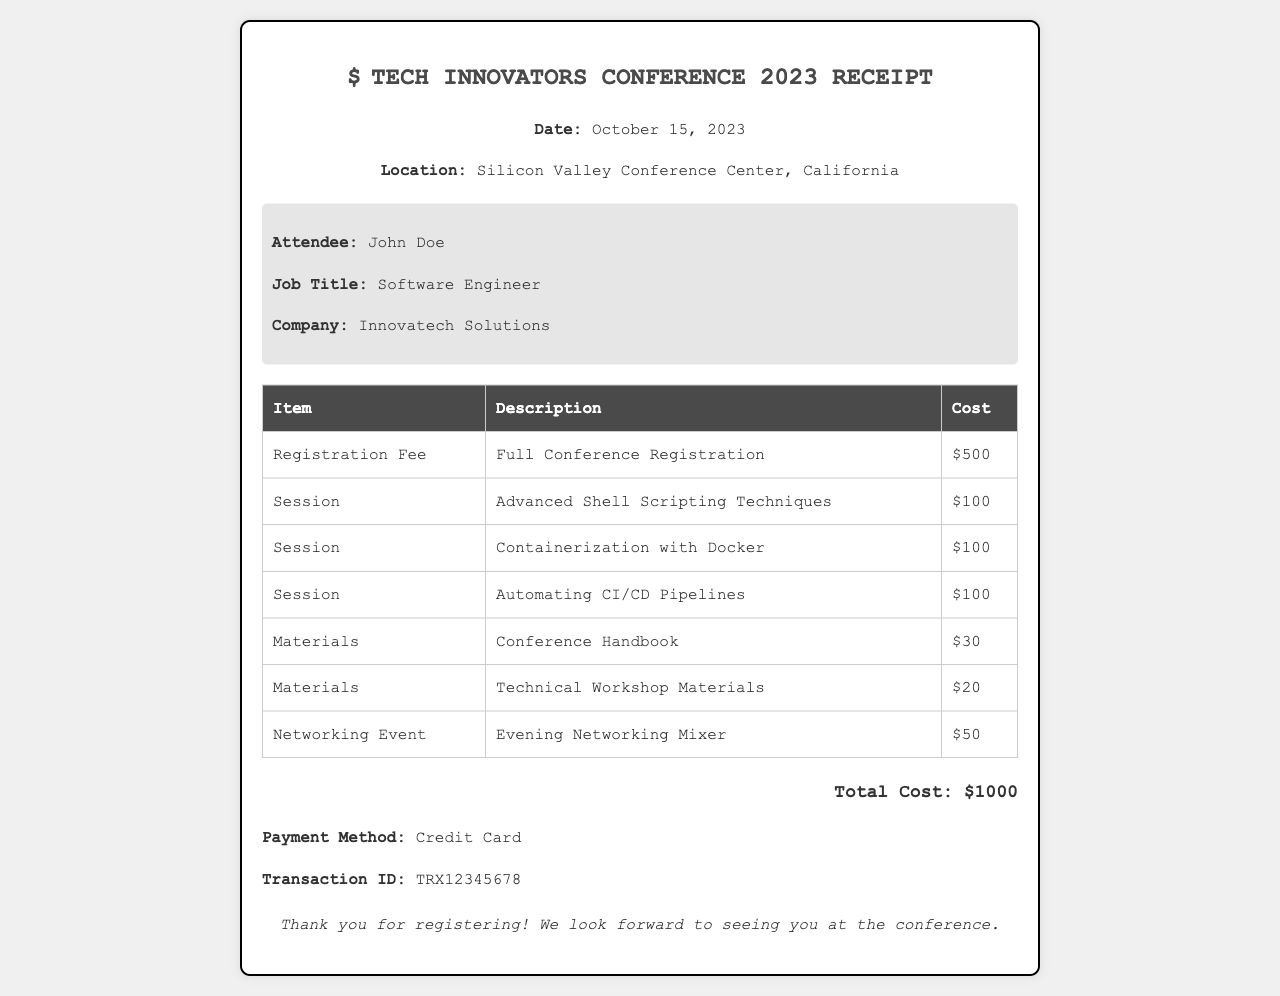What is the date of the conference? The date of the conference is stated in the document, which is October 15, 2023.
Answer: October 15, 2023 Who is the attendee? The name of the attendee is provided in the attendee information section, which is John Doe.
Answer: John Doe What is the total cost? The total cost is clearly mentioned at the bottom of the document as the sum of all expenses.
Answer: $1000 How many sessions were registered for? The document lists three sessions attended, specifically mentioning the session titles.
Answer: 3 What payment method was used? The payment method is stated under the payment details, which is Credit Card.
Answer: Credit Card What type of item is "Advanced Shell Scripting Techniques"? This item is categorized under sessions according to the table in the document.
Answer: Session What is the cost of the Conference Handbook? The cost of the Conference Handbook is specifically listed in the table.
Answer: $30 What is the transaction ID? The transaction ID is provided in the payment details section of the document.
Answer: TRX12345678 What is included in the Networking Event costs? The document specifies that the Networking Event costs include the Evening Networking Mixer.
Answer: Evening Networking Mixer 